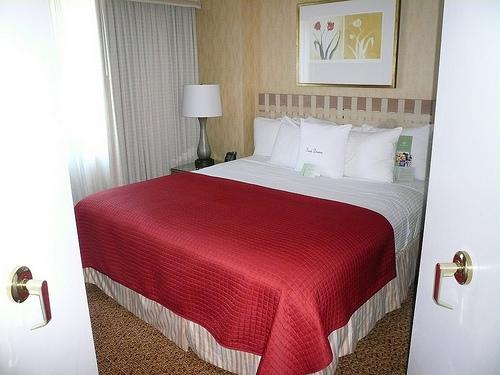What is the main color of the bedspread and the object hanging on the wall above the bed? The bedspread is primarily red and white, and the object on the wall above the bed is a picture. Briefly describe the general ambiance and mood of the image. The image has a serene and elegant ambiance, showcasing a well-decorated bedroom with a large bed, tasteful furnishings, and a harmonious color scheme. What is the main activity happening in the image, and describe the feeling it gives off? The image captures a peaceful and well-designed bedroom scene, but there is no specific activity taking place. What kind of door is in the image and what is its position relative to the bed? The image includes open double doors to the left of the bed with gold or brass handles. Identify and list all the objects on or beside the bed. There are white pillows, a red and white bedspread, a small clock on the bedside table, and a lamp with a white shade. What kind of handle is there on the doors and in what color? The door handles are gold and potentially made of brass. Examine the picture hanging on the wall and describe it briefly. The picture on the wall features some flowers and is framed; it is hanging above the bed. Describe the position and appearance of the lamp in the image. The lamp is on a table near the bed, and it has a white shade and a relatively tall base, possibly with gold accents. Identify the primary focus of the image and provide a brief description. The main focus is a bedroom scene featuring a bed with red and white bedspread, white pillows, and a picture hanging on the wall above it. How many white pillows are there on the bed? There are a total of five white pillows on the bed. 